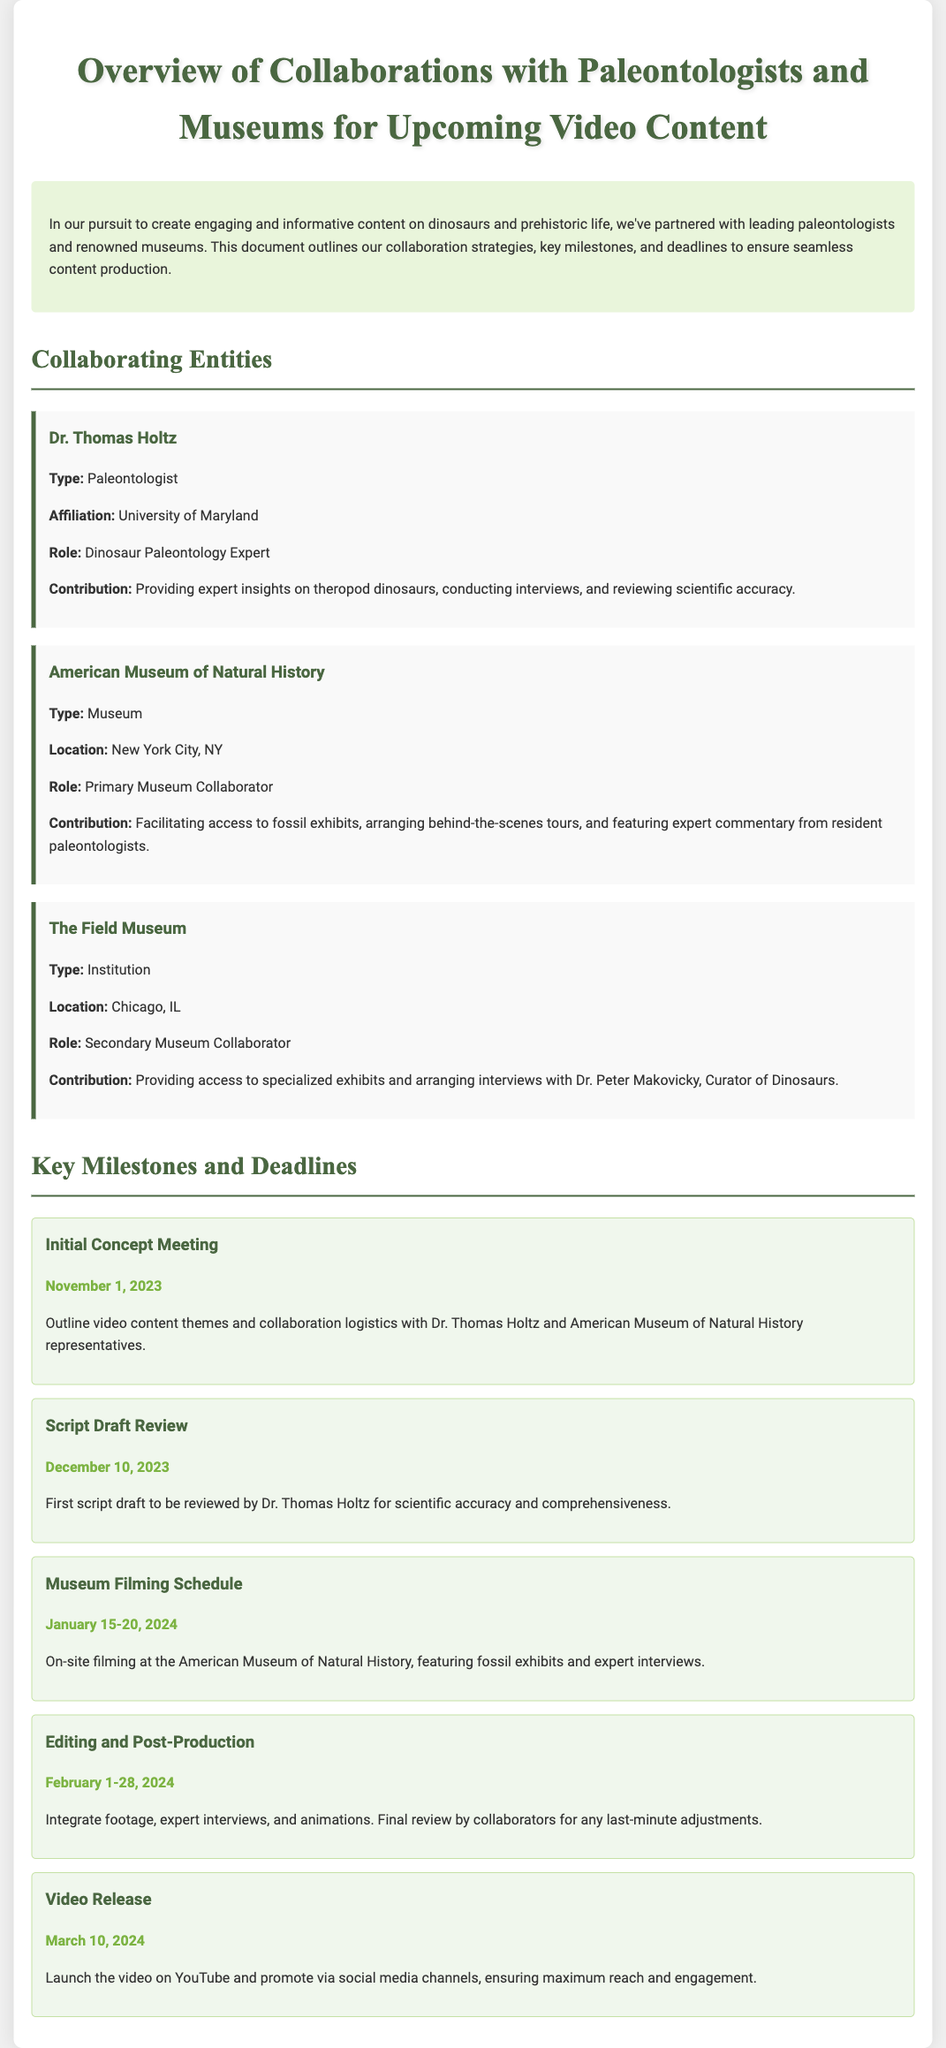What is the title of the document? The title of the document is presented prominently at the top, indicating the content focus on collaborations.
Answer: Overview of Collaborations with Paleontologists and Museums for Upcoming Video Content Who is Dr. Thomas Holtz? Dr. Thomas Holtz is mentioned as a key collaborator in the document and is identified by his role and affiliation.
Answer: Paleontologist When is the Initial Concept Meeting scheduled? The date for the Initial Concept Meeting is specified within the milestones section of the document.
Answer: November 1, 2023 What is the location of the American Museum of Natural History? The document states the location of this museum, which is noted for its significant contributions to the collaboration.
Answer: New York City, NY How many days are allocated for the Museum Filming Schedule? The duration of the filming period is explained in the milestones section, indicating a specific number of days for execution.
Answer: 5 days What type of institution is The Field Museum? Classification of The Field Museum's role in the collaboration is provided, helping to understand its contribution.
Answer: Institution What will be integrated during Editing and Post-Production? The details in the milestones section explain what will be combined during this phase of video production.
Answer: Footage, expert interviews, and animations When is the Video Release scheduled? The date for the release of the video is outlined in the milestones section, marking a significant deadline.
Answer: March 10, 2024 What is the role of the American Museum of Natural History? The document clearly outlines the role of this museum in the collaboration, emphasizing its contributions.
Answer: Primary Museum Collaborator 